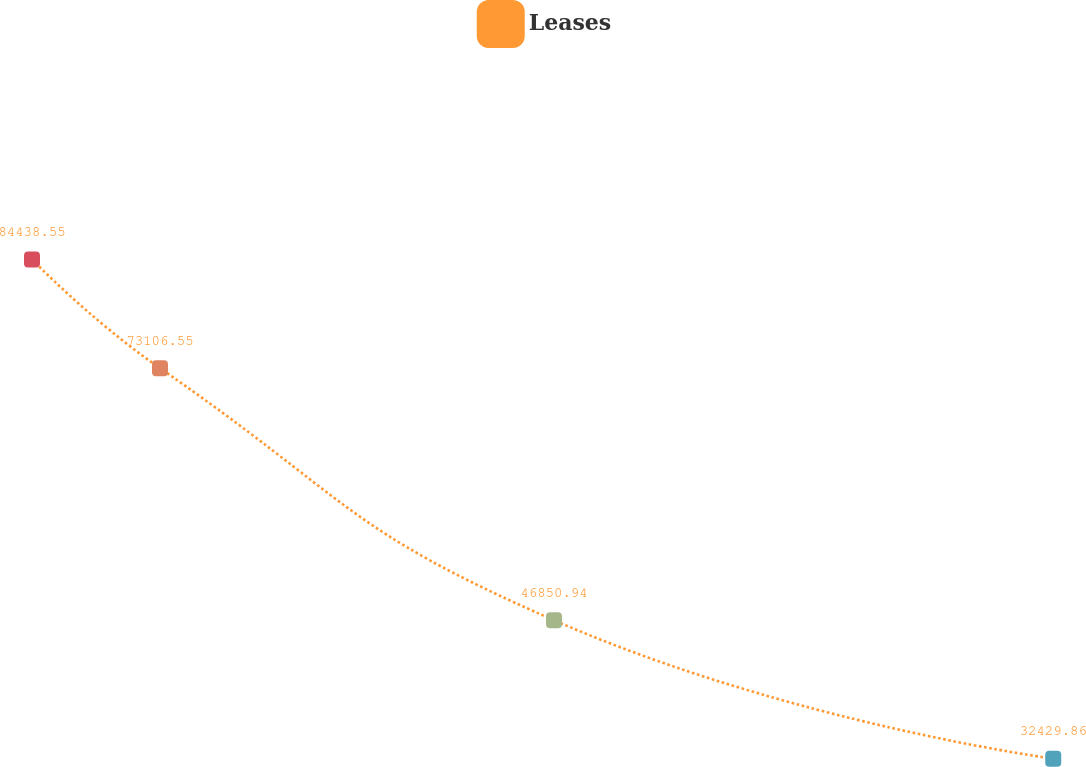Convert chart to OTSL. <chart><loc_0><loc_0><loc_500><loc_500><line_chart><ecel><fcel>Leases<nl><fcel>1688.61<fcel>84438.6<nl><fcel>1755.19<fcel>73106.6<nl><fcel>1960.16<fcel>46850.9<nl><fcel>2219.86<fcel>32429.9<nl><fcel>2354.46<fcel>37630.7<nl></chart> 